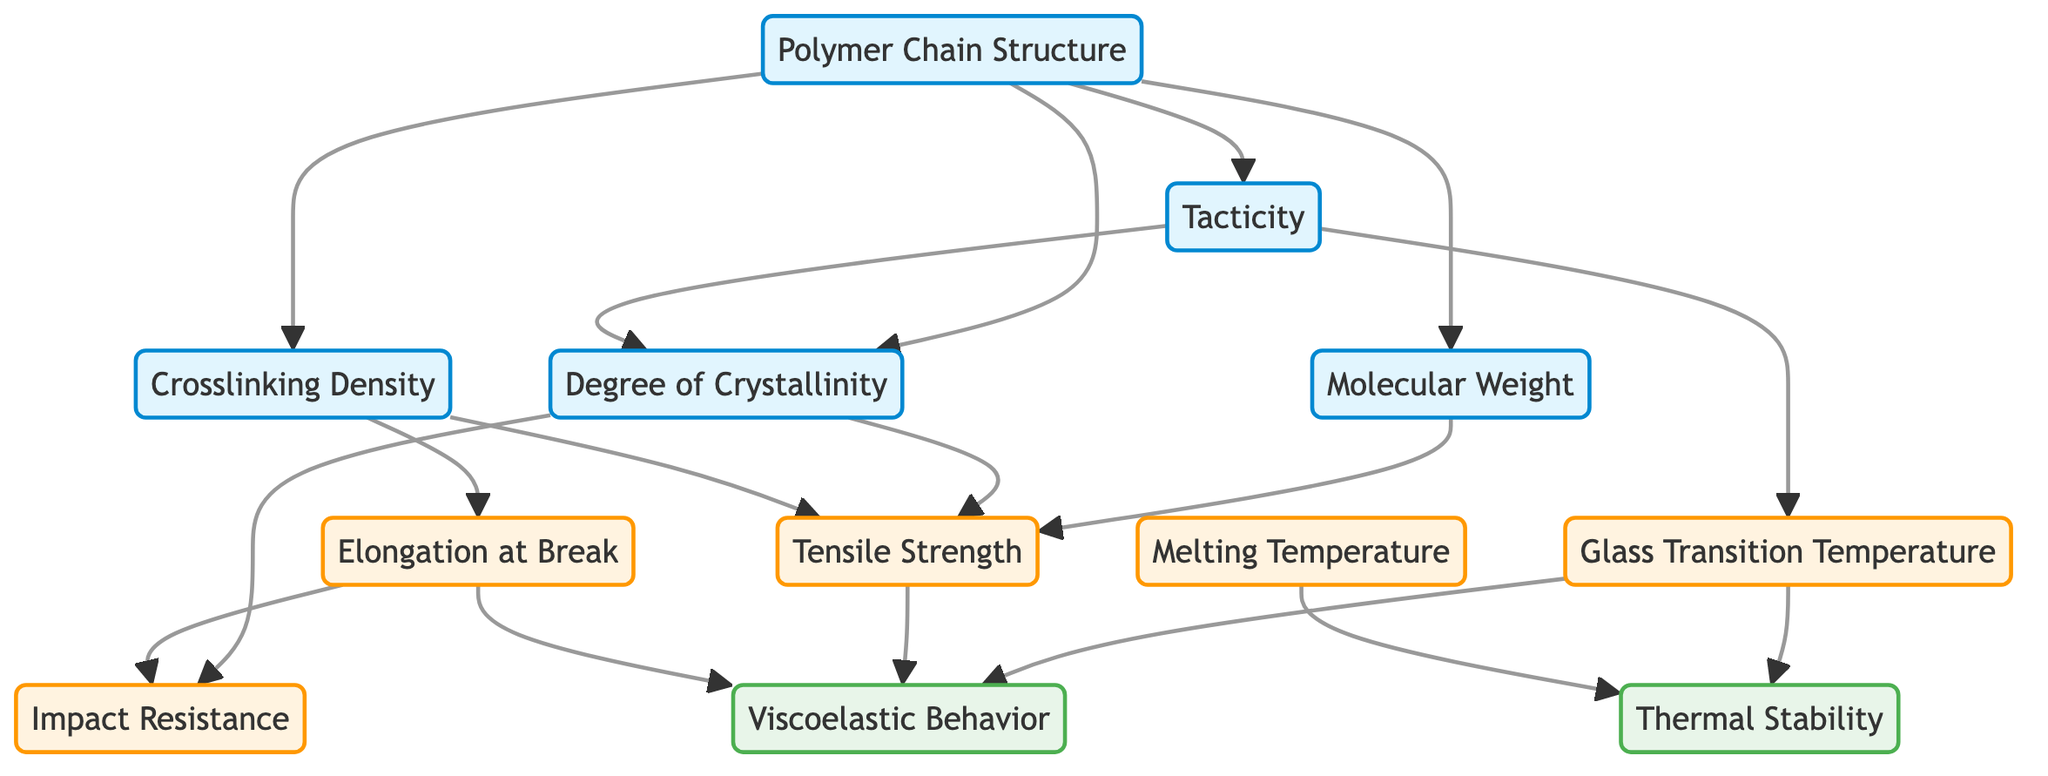What is the relationship between Polymer Chain Structure and Degree of Crystallinity? The Polymer Chain Structure directly influences the Degree of Crystallinity according to the diagram, as indicated by a connecting arrow from Polymer Chain Structure to Degree of Crystallinity.
Answer: Direct influence How many nodes are there in the diagram? By counting each unique node represented in the diagram, we find that there are 12 nodes.
Answer: 12 What is the connection between Tacticity and Glass Transition Temperature? The diagram shows a direct connection from Tacticity to Glass Transition Temperature, indicating that Tacticity affects the Glass Transition Temperature.
Answer: Affects Which property is influenced by both Molecular Weight and Degree of Crystallinity? The diagram shows that both Molecular Weight and Degree of Crystallinity lead to increased Tensile Strength, indicating a direct influence on this property.
Answer: Tensile Strength Which two properties are affected by Elongation at Break? From the diagram, Elongation at Break has direct influences on Impact Resistance and Viscoelastic Behavior, as shown by connecting arrows to both properties.
Answer: Impact Resistance, Viscoelastic Behavior What is implied by the connection from the Degree of Crystallinity to Impact Resistance? The connecting arrow from Degree of Crystallinity to Impact Resistance implies that an increase in Degree of Crystallinity may enhance the Impact Resistance of the polymer.
Answer: Enhance What property is linked to Thermal Stability through multiple nodes? The nodes Glass Transition Temperature and Melting Temperature both connect to Thermal Stability, indicating that multiple factors influence this property.
Answer: Thermal Stability Which property does Polymer Chain Structure not directly relate to? The Polymer Chain Structure does not directly relate to Melting Temperature, as there is no connecting arrow from Polymer Chain Structure to Melting Temperature in the diagram.
Answer: Melting Temperature How does Tacticity influence Degree of Crystallinity? The diagram indicates that Tacticity directly influences Degree of Crystallinity because there is a connecting arrow from Tacticity to Degree of Crystallinity.
Answer: Direct influence 